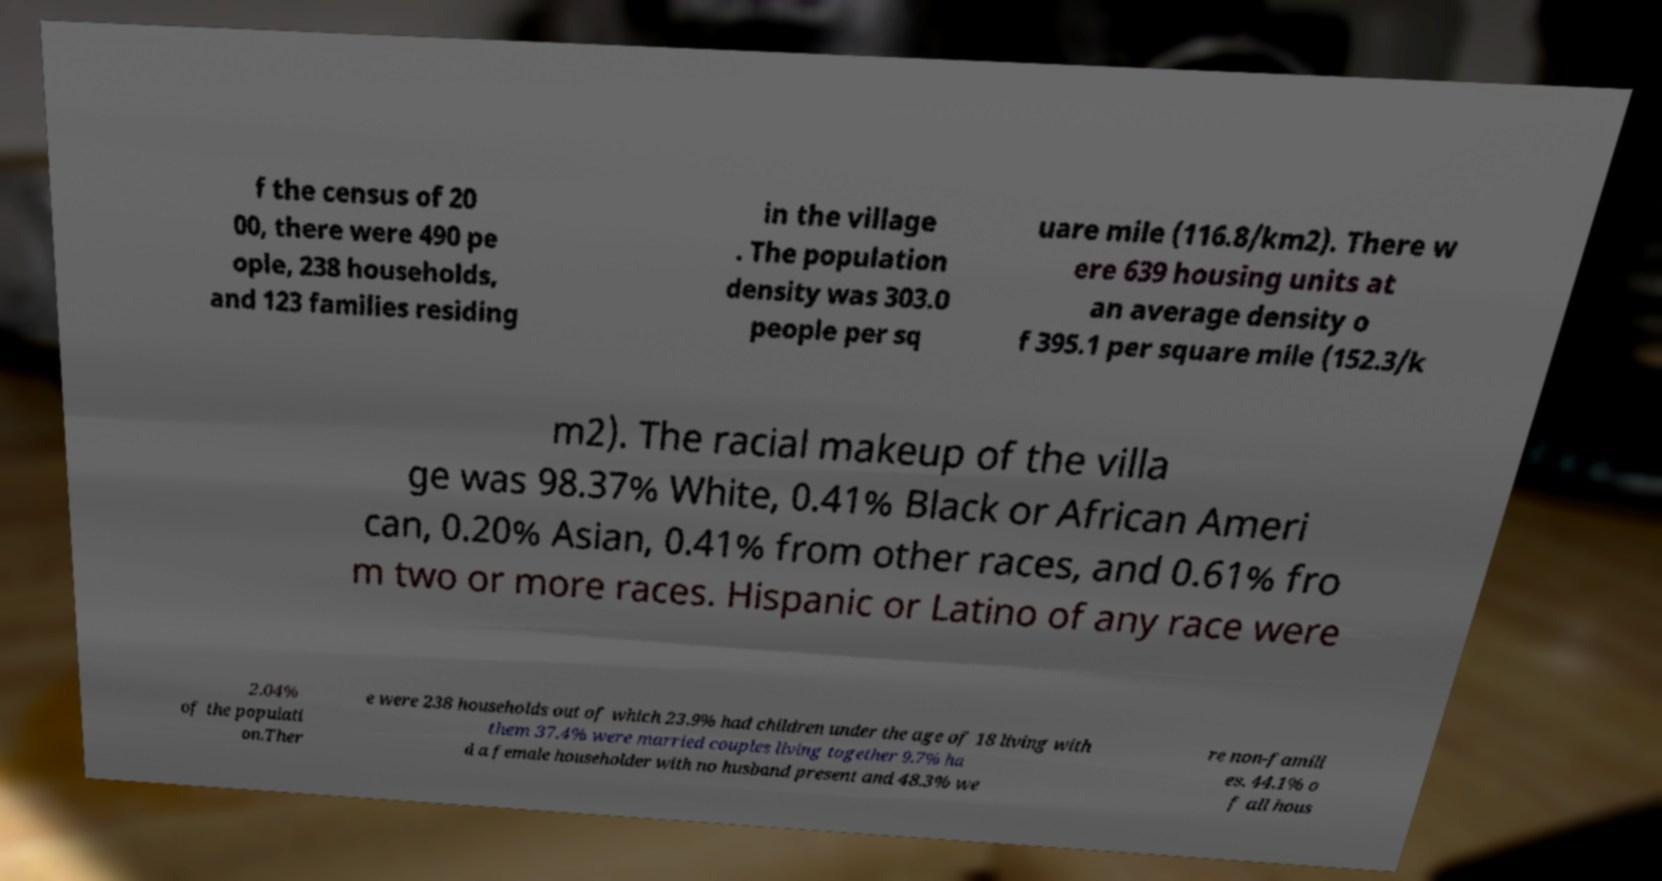Please read and relay the text visible in this image. What does it say? f the census of 20 00, there were 490 pe ople, 238 households, and 123 families residing in the village . The population density was 303.0 people per sq uare mile (116.8/km2). There w ere 639 housing units at an average density o f 395.1 per square mile (152.3/k m2). The racial makeup of the villa ge was 98.37% White, 0.41% Black or African Ameri can, 0.20% Asian, 0.41% from other races, and 0.61% fro m two or more races. Hispanic or Latino of any race were 2.04% of the populati on.Ther e were 238 households out of which 23.9% had children under the age of 18 living with them 37.4% were married couples living together 9.7% ha d a female householder with no husband present and 48.3% we re non-famili es. 44.1% o f all hous 